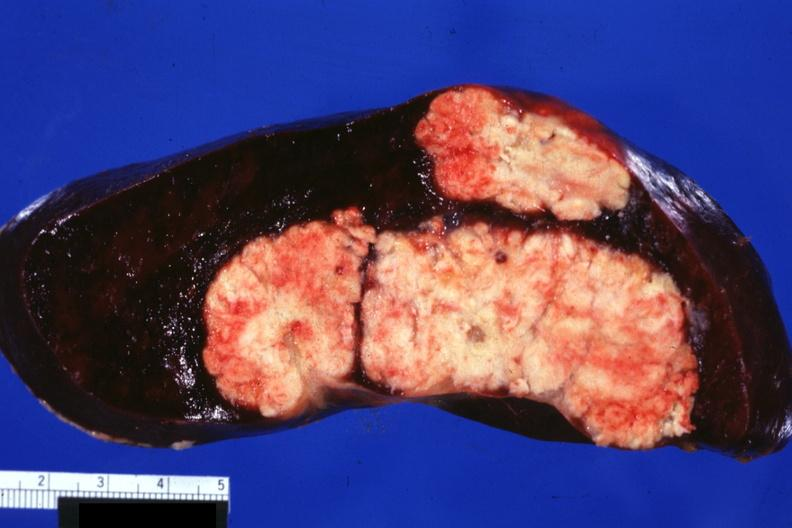s previous slide from this case present?
Answer the question using a single word or phrase. No 